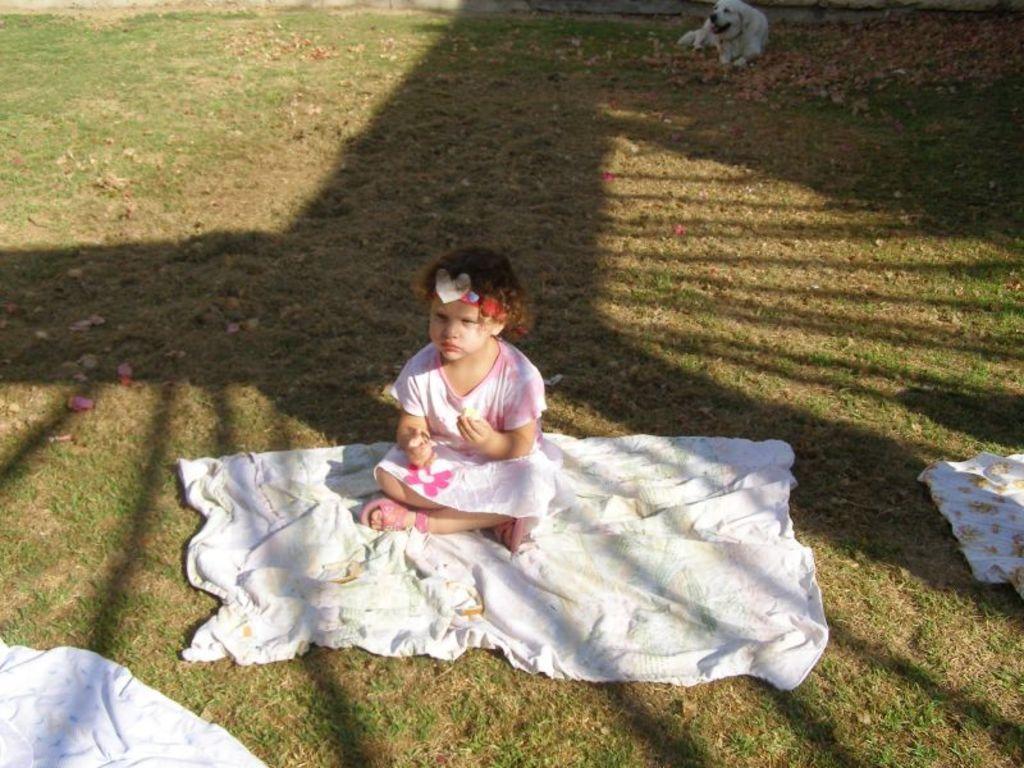How would you summarize this image in a sentence or two? In this image there is a child sitting on the cloth, which is on the surface of the grass and there are a few other clothes, in the background there is a dog. 